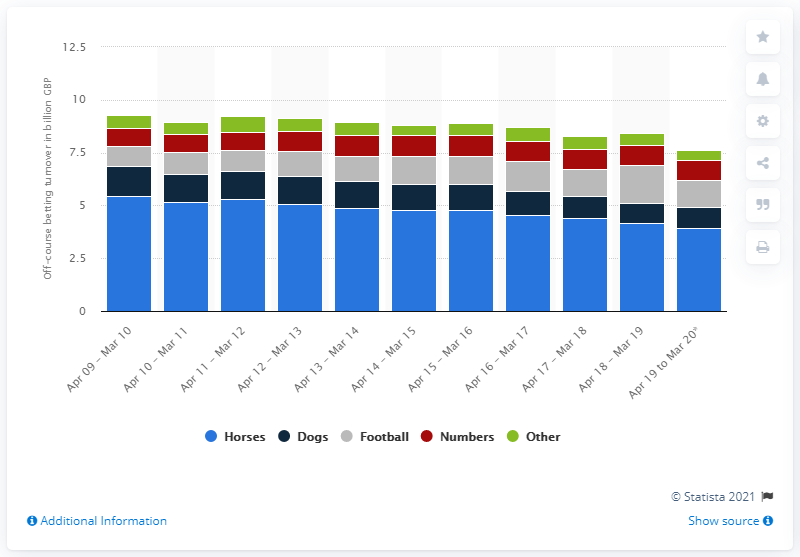Indicate a few pertinent items in this graphic. From April 2019 to March 2020, the amount of horse betting revenue was 3.95. The total revenue generated from horse betting in the previous year was 4.19 billion dollars. 